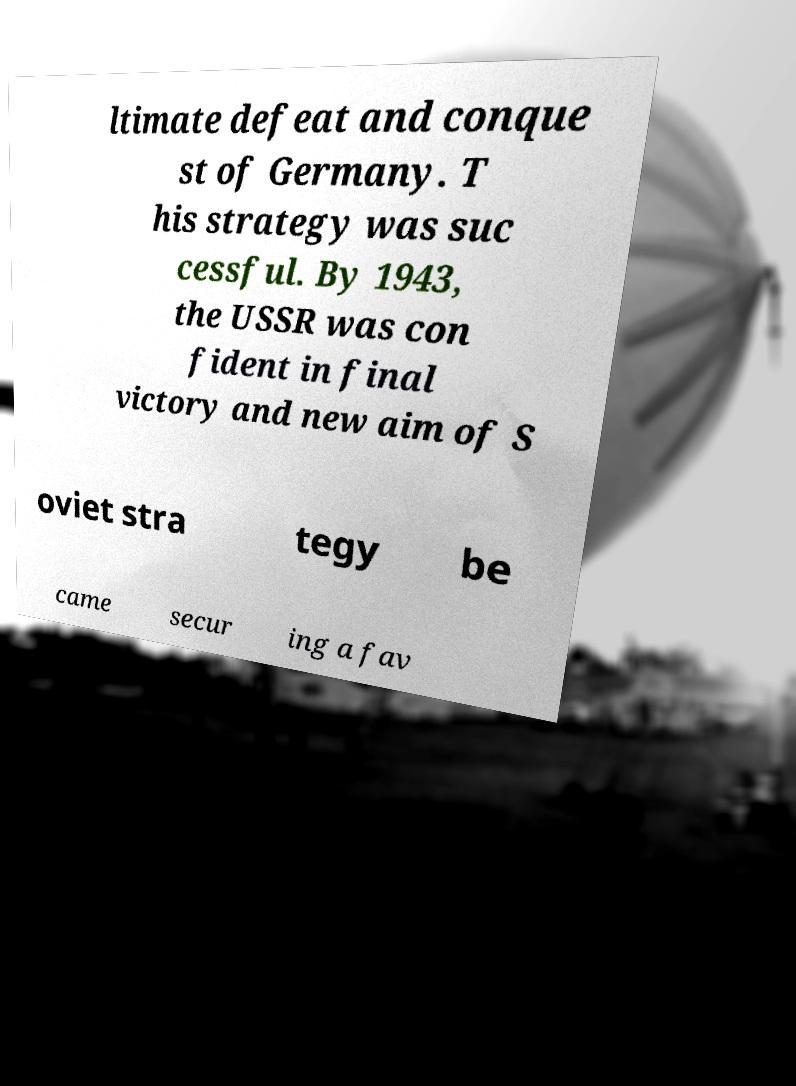Can you accurately transcribe the text from the provided image for me? ltimate defeat and conque st of Germany. T his strategy was suc cessful. By 1943, the USSR was con fident in final victory and new aim of S oviet stra tegy be came secur ing a fav 